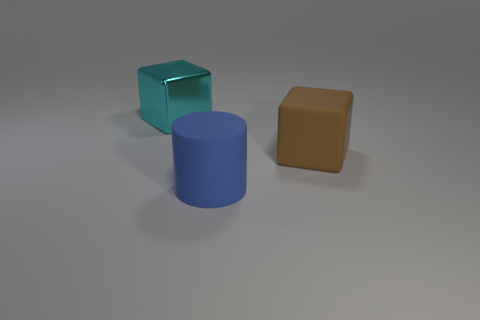Subtract all cylinders. How many objects are left? 2 Add 1 cubes. How many objects exist? 4 Add 1 big brown rubber things. How many big brown rubber things are left? 2 Add 3 big cyan metallic blocks. How many big cyan metallic blocks exist? 4 Subtract 0 brown cylinders. How many objects are left? 3 Subtract all small purple metallic cubes. Subtract all metal blocks. How many objects are left? 2 